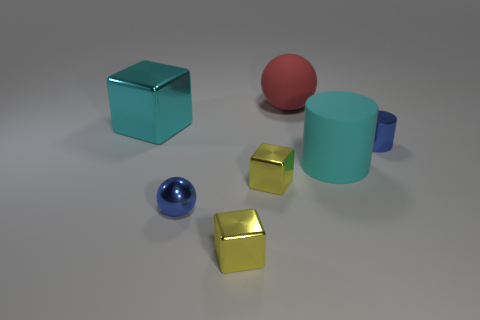Are there any red rubber objects right of the ball behind the large thing that is in front of the cyan metallic object?
Offer a very short reply. No. There is a blue metal thing that is to the right of the large matte sphere; how big is it?
Provide a short and direct response. Small. There is a cylinder that is the same size as the red matte sphere; what is its material?
Give a very brief answer. Rubber. Do the large red thing and the cyan matte object have the same shape?
Provide a succinct answer. No. What number of objects are metal cylinders or shiny cubes that are on the right side of the small metallic sphere?
Make the answer very short. 3. What material is the block that is the same color as the large matte cylinder?
Offer a very short reply. Metal. Does the blue object that is in front of the blue cylinder have the same size as the tiny blue cylinder?
Ensure brevity in your answer.  Yes. How many big red matte balls are right of the matte ball to the right of the blue shiny object in front of the big cyan matte object?
Keep it short and to the point. 0. How many gray objects are either rubber cylinders or small metallic balls?
Your answer should be compact. 0. What color is the large thing that is the same material as the large red sphere?
Provide a succinct answer. Cyan. 